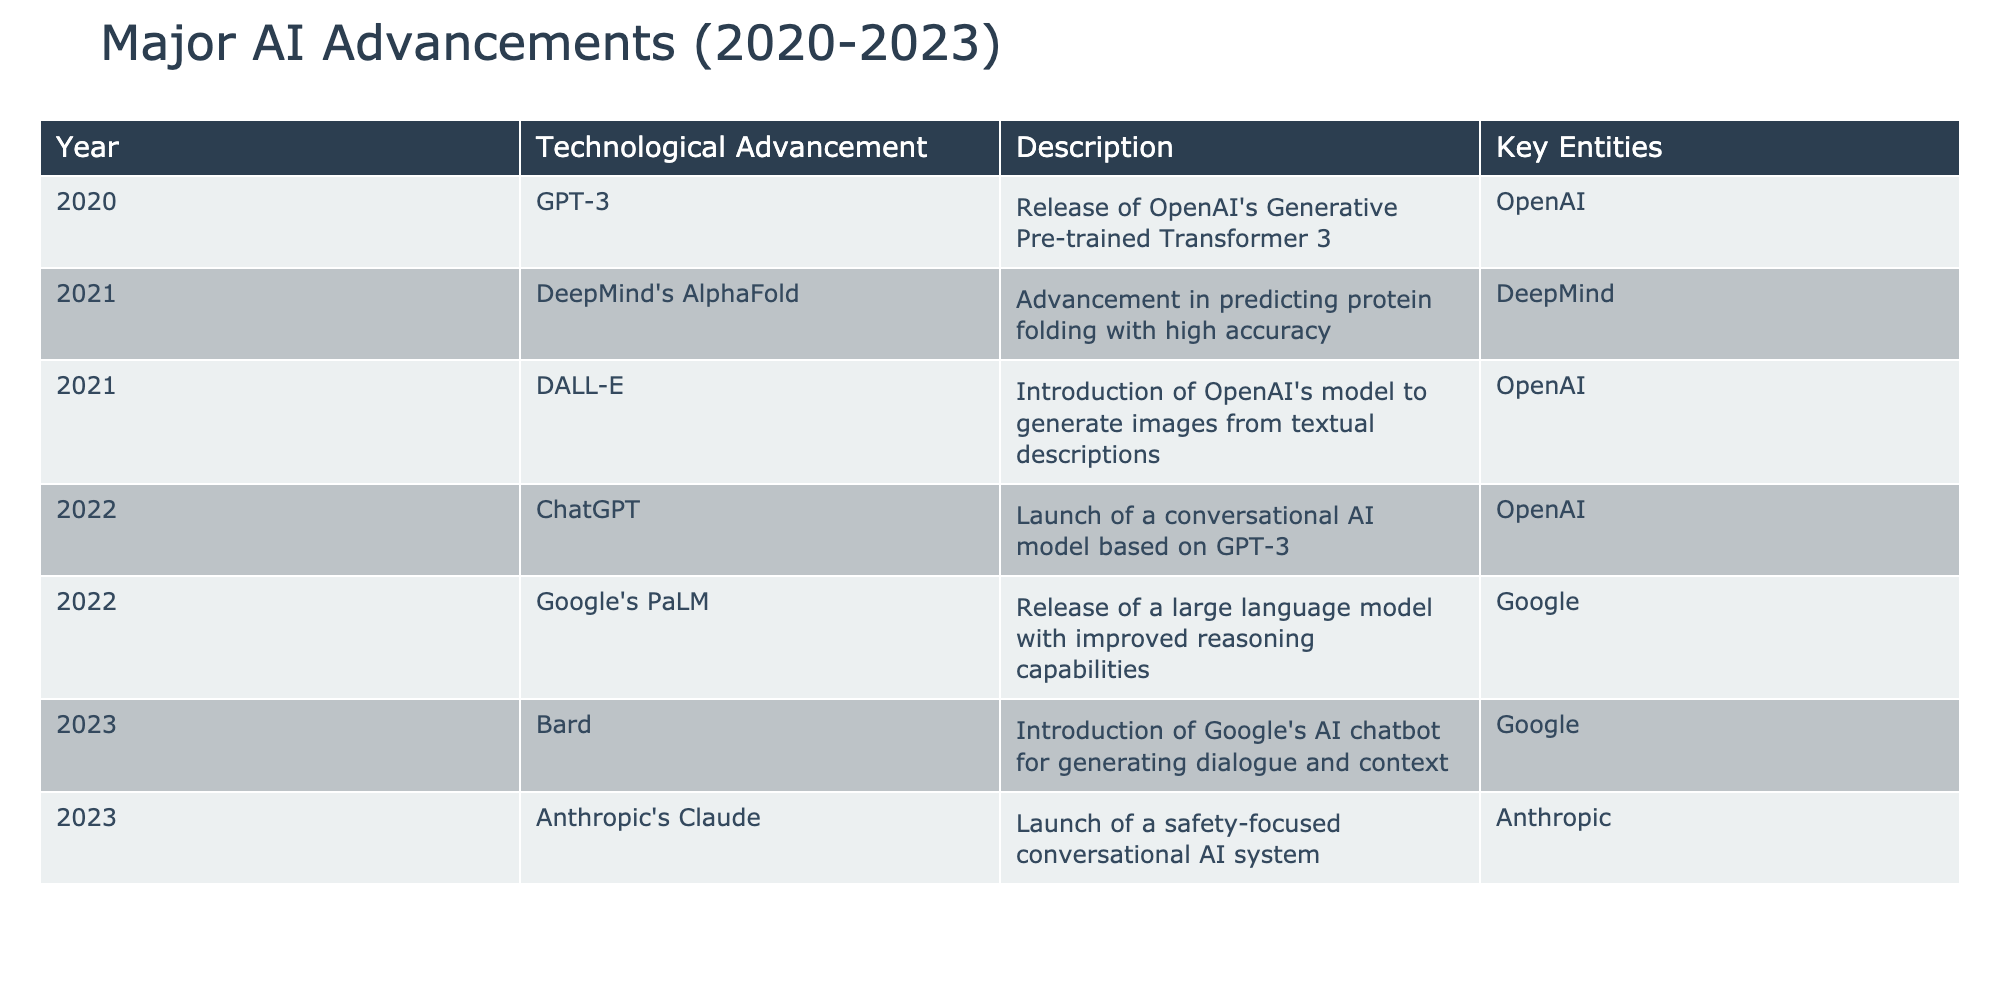What was the first major AI advancement listed in the table? The table starts with the entry for 2020, which is GPT-3, released by OpenAI.
Answer: GPT-3 Which company launched ChatGPT and in which year? According to the table, ChatGPT was launched by OpenAI in 2022.
Answer: OpenAI, 2022 True or False: DALL-E was released in 2020. The table shows that DALL-E was launched in 2021, not 2020.
Answer: False What are the key entities for the advancements made in 2023? The table lists two advancements for 2023: Bard and Anthropic's Claude, with Google and Anthropic being their respective key entities.
Answer: Google, Anthropic Which technological advancement represents a significant improvement in reasoning capabilities relative to previous models? The table mentions Google's PaLM in 2022 as having improved reasoning capabilities compared to its predecessors.
Answer: Google's PaLM How many AI advancements were introduced by OpenAI between 2020 and 2022? The table shows three advancements attributable to OpenAI: GPT-3 (2020), DALL-E (2021), and ChatGPT (2022), totaling three.
Answer: 3 Which technological advancement came after DeepMind's AlphaFold and what year was it released? After AlphaFold, which was released in 2021, the next advancement was DALL-E, also released in 2021.
Answer: DALL-E, 2021 What is the predominant theme of AI advancements listed in 2022? The table indicates that 2022 saw the release of more conversational AI technologies, notably ChatGPT and Google's PaLM, marking a thematic focus on enhancing dialogue and reasoning in AI.
Answer: Conversational AI technologies Which advancement was focused on safety and who developed it? The advancement focused on safety is Anthropic's Claude, which is specified in the table as launched in 2023.
Answer: Anthropic's Claude 